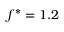Convert formula to latex. <formula><loc_0><loc_0><loc_500><loc_500>f ^ { * } = 1 . 2</formula> 